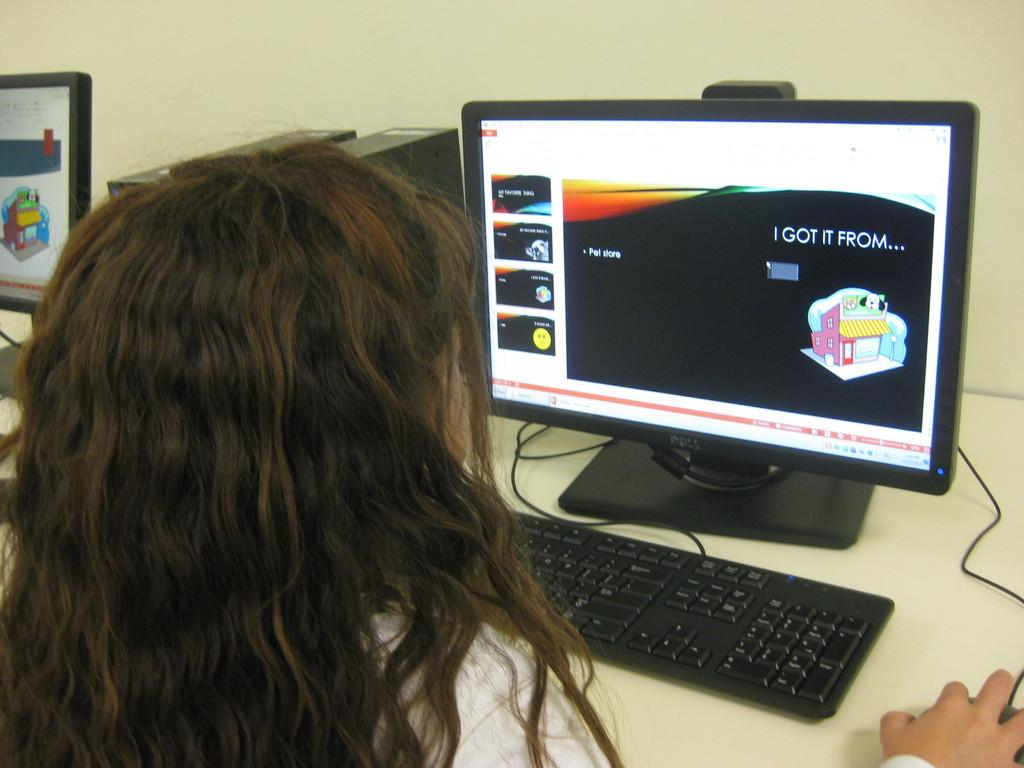<image>
Give a short and clear explanation of the subsequent image. A person sits at a computer monitor with I Got It From written on the screen. 